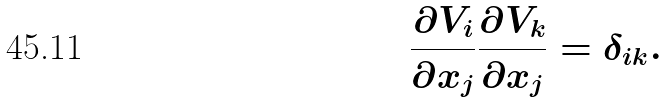<formula> <loc_0><loc_0><loc_500><loc_500>\frac { \partial V _ { i } } { \partial x _ { j } } \frac { \partial V _ { k } } { \partial x _ { j } } = \delta _ { i k } .</formula> 